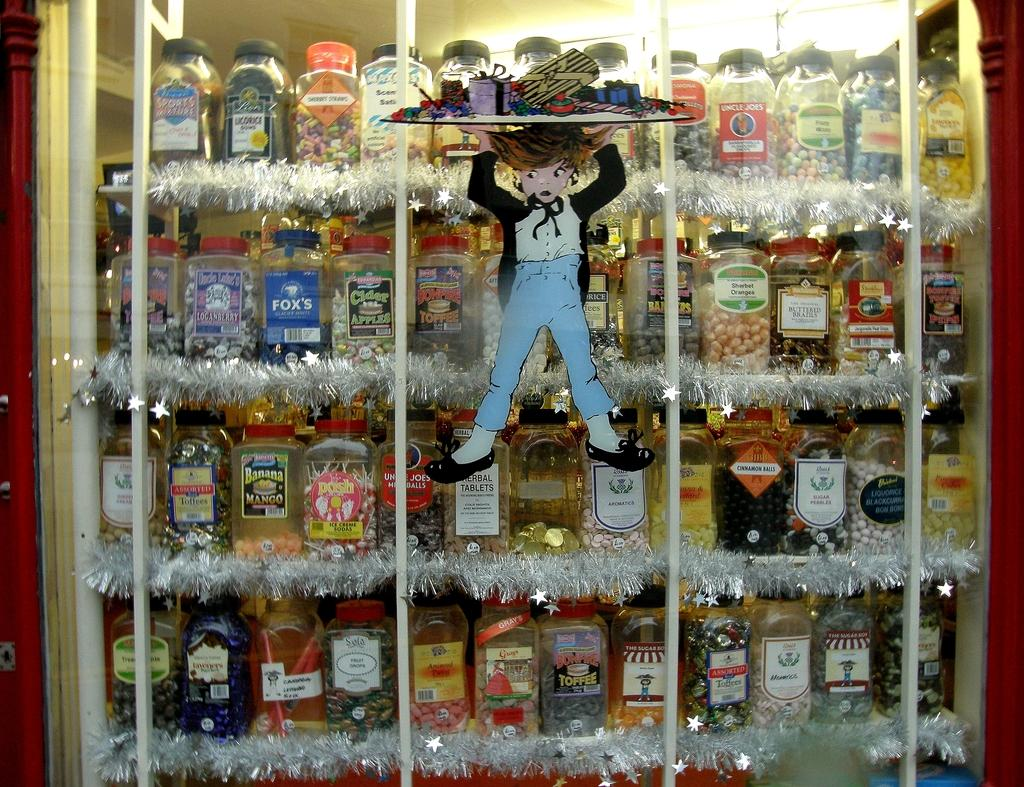<image>
Present a compact description of the photo's key features. I store front display of many types of booze like Banana Mango. 